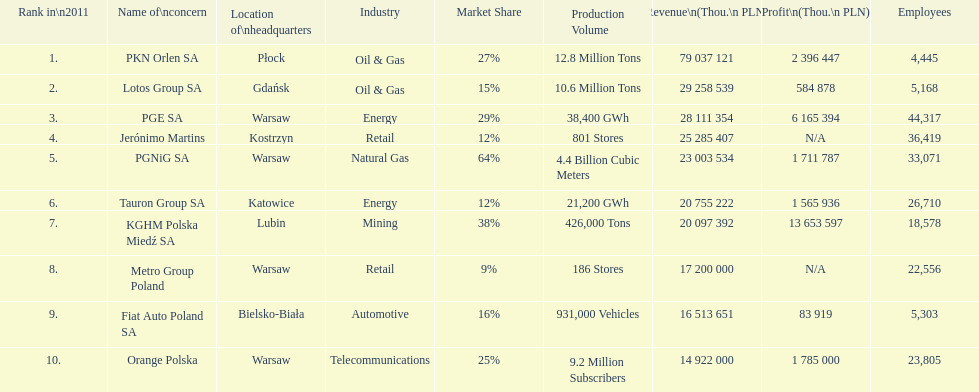What company is the only one with a revenue greater than 75,000,000 thou. pln? PKN Orlen SA. 